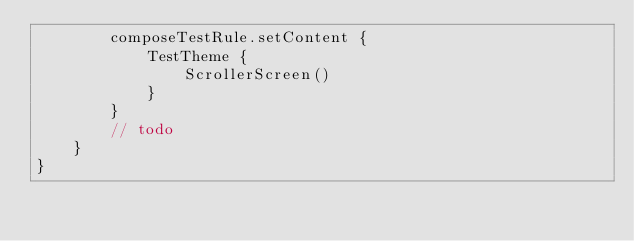<code> <loc_0><loc_0><loc_500><loc_500><_Kotlin_>        composeTestRule.setContent {
            TestTheme {
                ScrollerScreen()
            }
        }
        // todo
    }
}</code> 